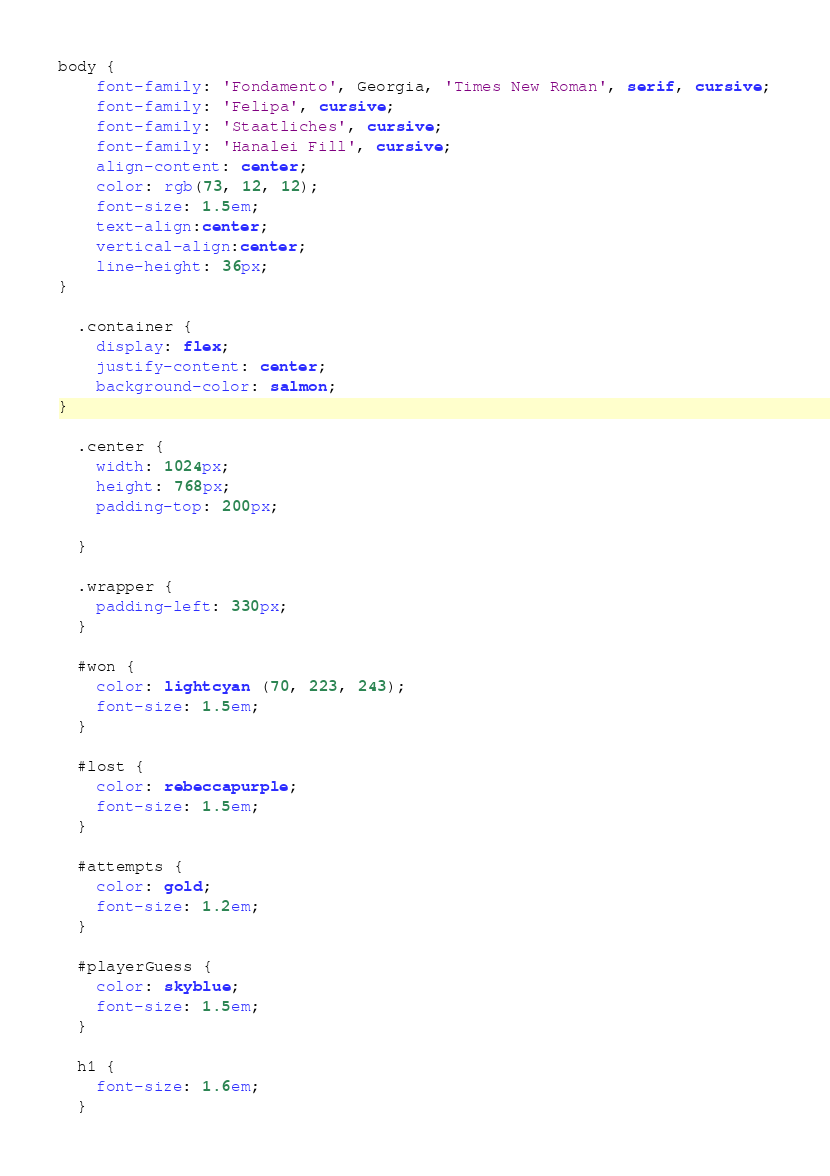<code> <loc_0><loc_0><loc_500><loc_500><_CSS_>body {
    font-family: 'Fondamento', Georgia, 'Times New Roman', serif, cursive;
    font-family: 'Felipa', cursive;
    font-family: 'Staatliches', cursive;
    font-family: 'Hanalei Fill', cursive;
    align-content: center;      
    color: rgb(73, 12, 12);      
    font-size: 1.5em;
    text-align:center;
    vertical-align:center;
    line-height: 36px;  
}

  .container {
    display: flex;
    justify-content: center;
    background-color: salmon;   
}

  .center {      
    width: 1024px;
    height: 768px;
    padding-top: 200px;      
   
  }

  .wrapper {
    padding-left: 330px;
  }

  #won {
    color: lightcyan (70, 223, 243);
    font-size: 1.5em;
  }

  #lost {
    color: rebeccapurple;
    font-size: 1.5em;
  }

  #attempts {
    color: gold;
    font-size: 1.2em;
  }

  #playerGuess {
    color: skyblue;
    font-size: 1.5em;
  }

  h1 {
    font-size: 1.6em;
  }</code> 